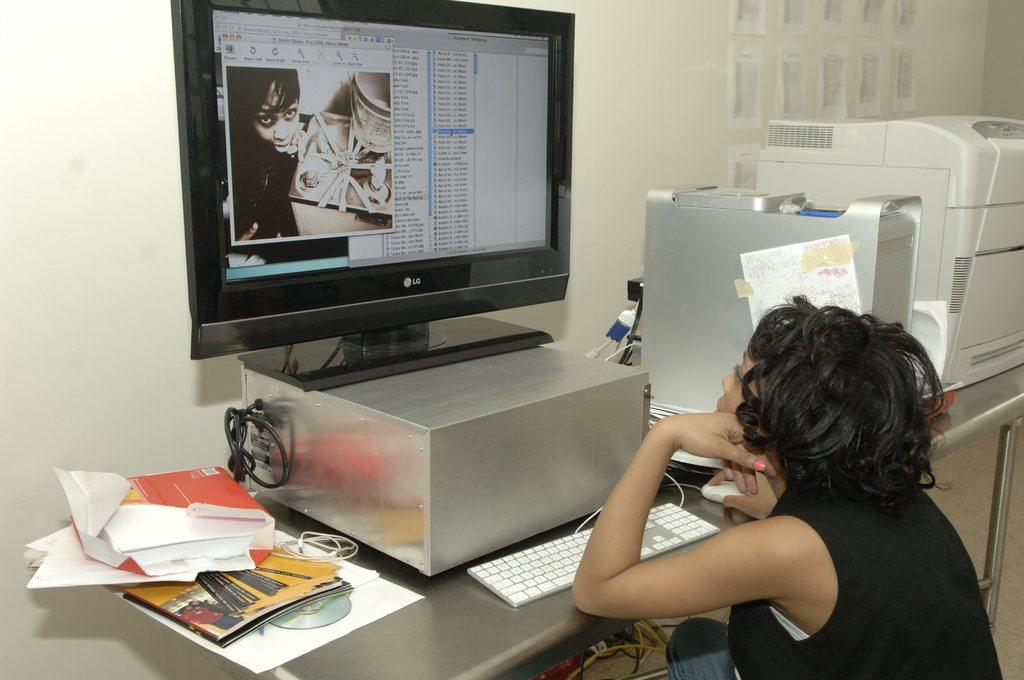What is the woman in the image doing? The woman is sitting and watching a monitor in the image. What objects can be seen on the table in the image? There is an LCD TV, a keyboard, a book, a CPU, and another device on the table in the image. What type of furniture is present in the image? There is a table and a desk in the image. What type of spring can be seen in the image? There is no spring present in the image. Is there a box on the table in the image? The provided facts do not mention a box on the table in the image. --- Facts: 1. There is a car in the image. 2. The car is parked on the street. 3. There are trees on the street. 4. There is a sidewalk in the image. 5. There is a streetlight on the sidewalk. 6. There is a fire hydrant on the sidewalk. Absurd Topics: lion Conversation: What is the main subject in the image? There is a car in the image. Where is the car located? The car is parked on the street in the image. What else can be seen on the street? There are trees on the street in the image. What type of infrastructure is present in the image? There is a sidewalk in the image, and there is a streetlight and a fire hydrant on the sidewalk. Reasoning: Let's think step by step in order to produce the conversation. We start by identifying the main subject of the image, which is the car. Next, we describe the location of the car, which is parked on the street. Then, we observe the elements on the street, such as the trees. After that, we identify the type of infrastructure present in the image, which includes the sidewalk, the streetlight, and the fire hydrant. Absurd Question/Answer: What type of lion can be seen in the image? There is no lion present in the image. 